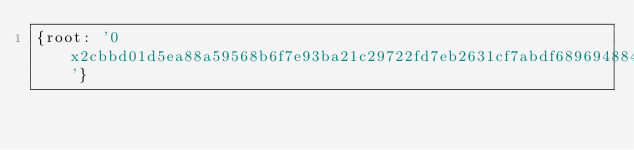Convert code to text. <code><loc_0><loc_0><loc_500><loc_500><_YAML_>{root: '0x2cbbd01d5ea88a59568b6f7e93ba21c29722fd7eb2631cf7abdf689694884ab8'}
</code> 